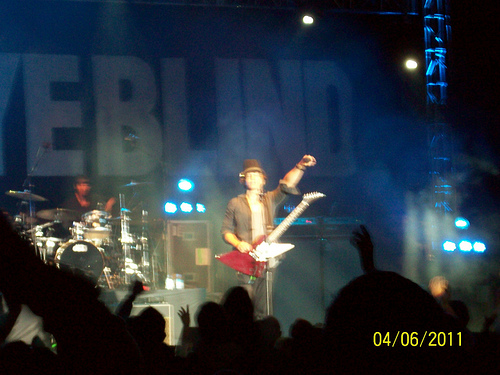<image>
Can you confirm if the guitar is in front of the stage? No. The guitar is not in front of the stage. The spatial positioning shows a different relationship between these objects. 